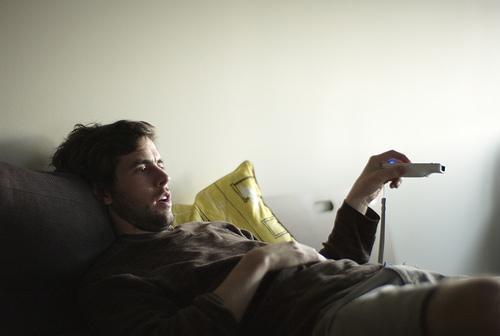How many people are there?
Give a very brief answer. 1. 